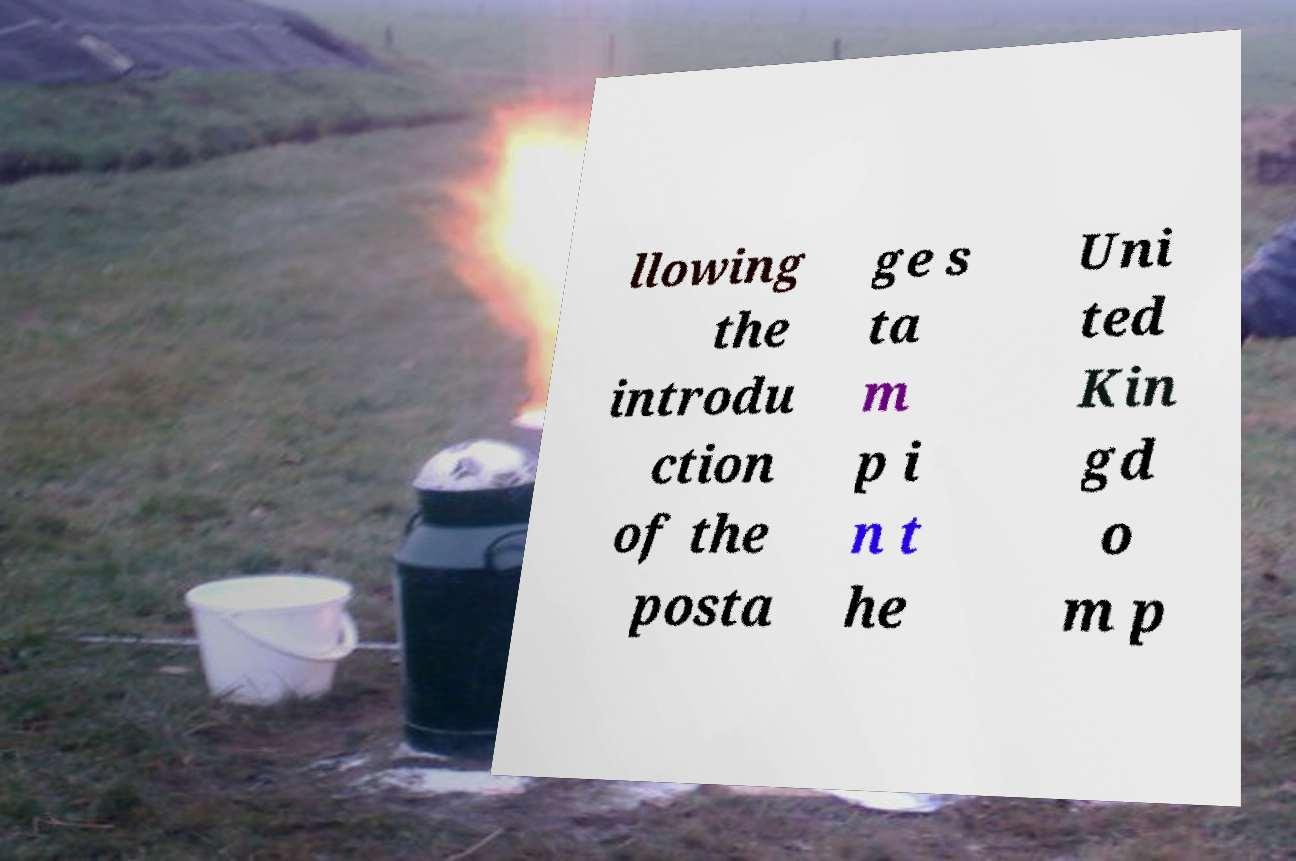For documentation purposes, I need the text within this image transcribed. Could you provide that? llowing the introdu ction of the posta ge s ta m p i n t he Uni ted Kin gd o m p 